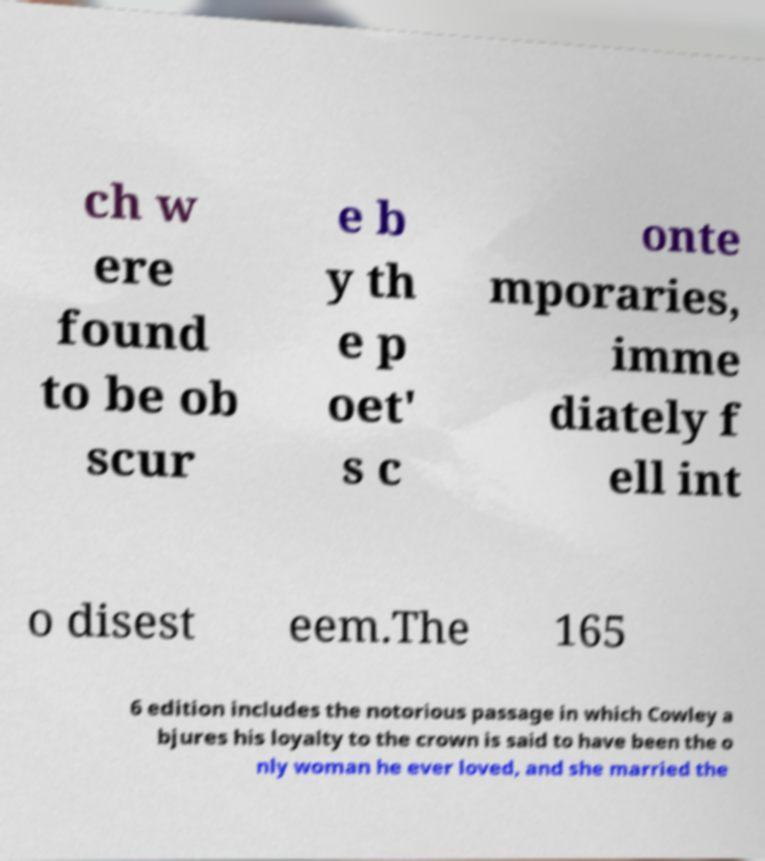There's text embedded in this image that I need extracted. Can you transcribe it verbatim? ch w ere found to be ob scur e b y th e p oet' s c onte mporaries, imme diately f ell int o disest eem.The 165 6 edition includes the notorious passage in which Cowley a bjures his loyalty to the crown is said to have been the o nly woman he ever loved, and she married the 